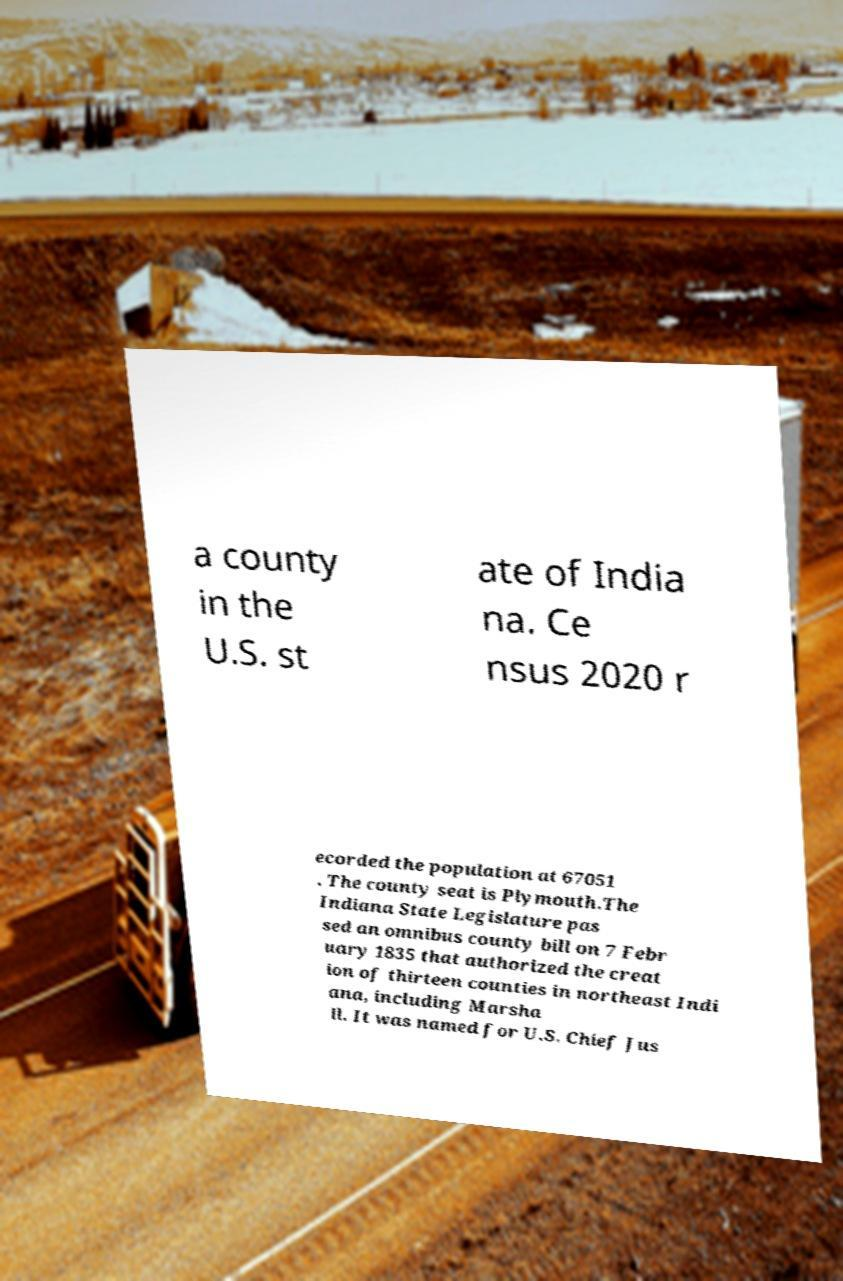What messages or text are displayed in this image? I need them in a readable, typed format. a county in the U.S. st ate of India na. Ce nsus 2020 r ecorded the population at 67051 . The county seat is Plymouth.The Indiana State Legislature pas sed an omnibus county bill on 7 Febr uary 1835 that authorized the creat ion of thirteen counties in northeast Indi ana, including Marsha ll. It was named for U.S. Chief Jus 